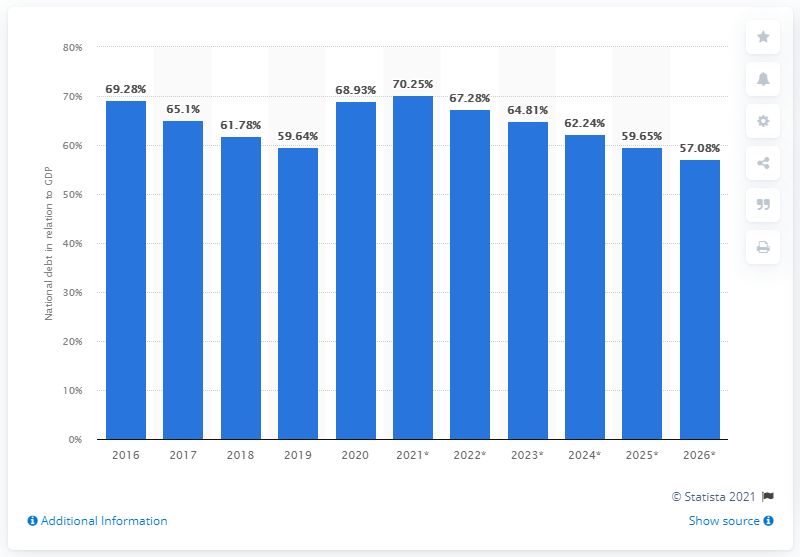Specify some key components in this picture. In 2020, the national debt of Germany accounted for approximately 68.93% of the country's Gross Domestic Product (GDP). 